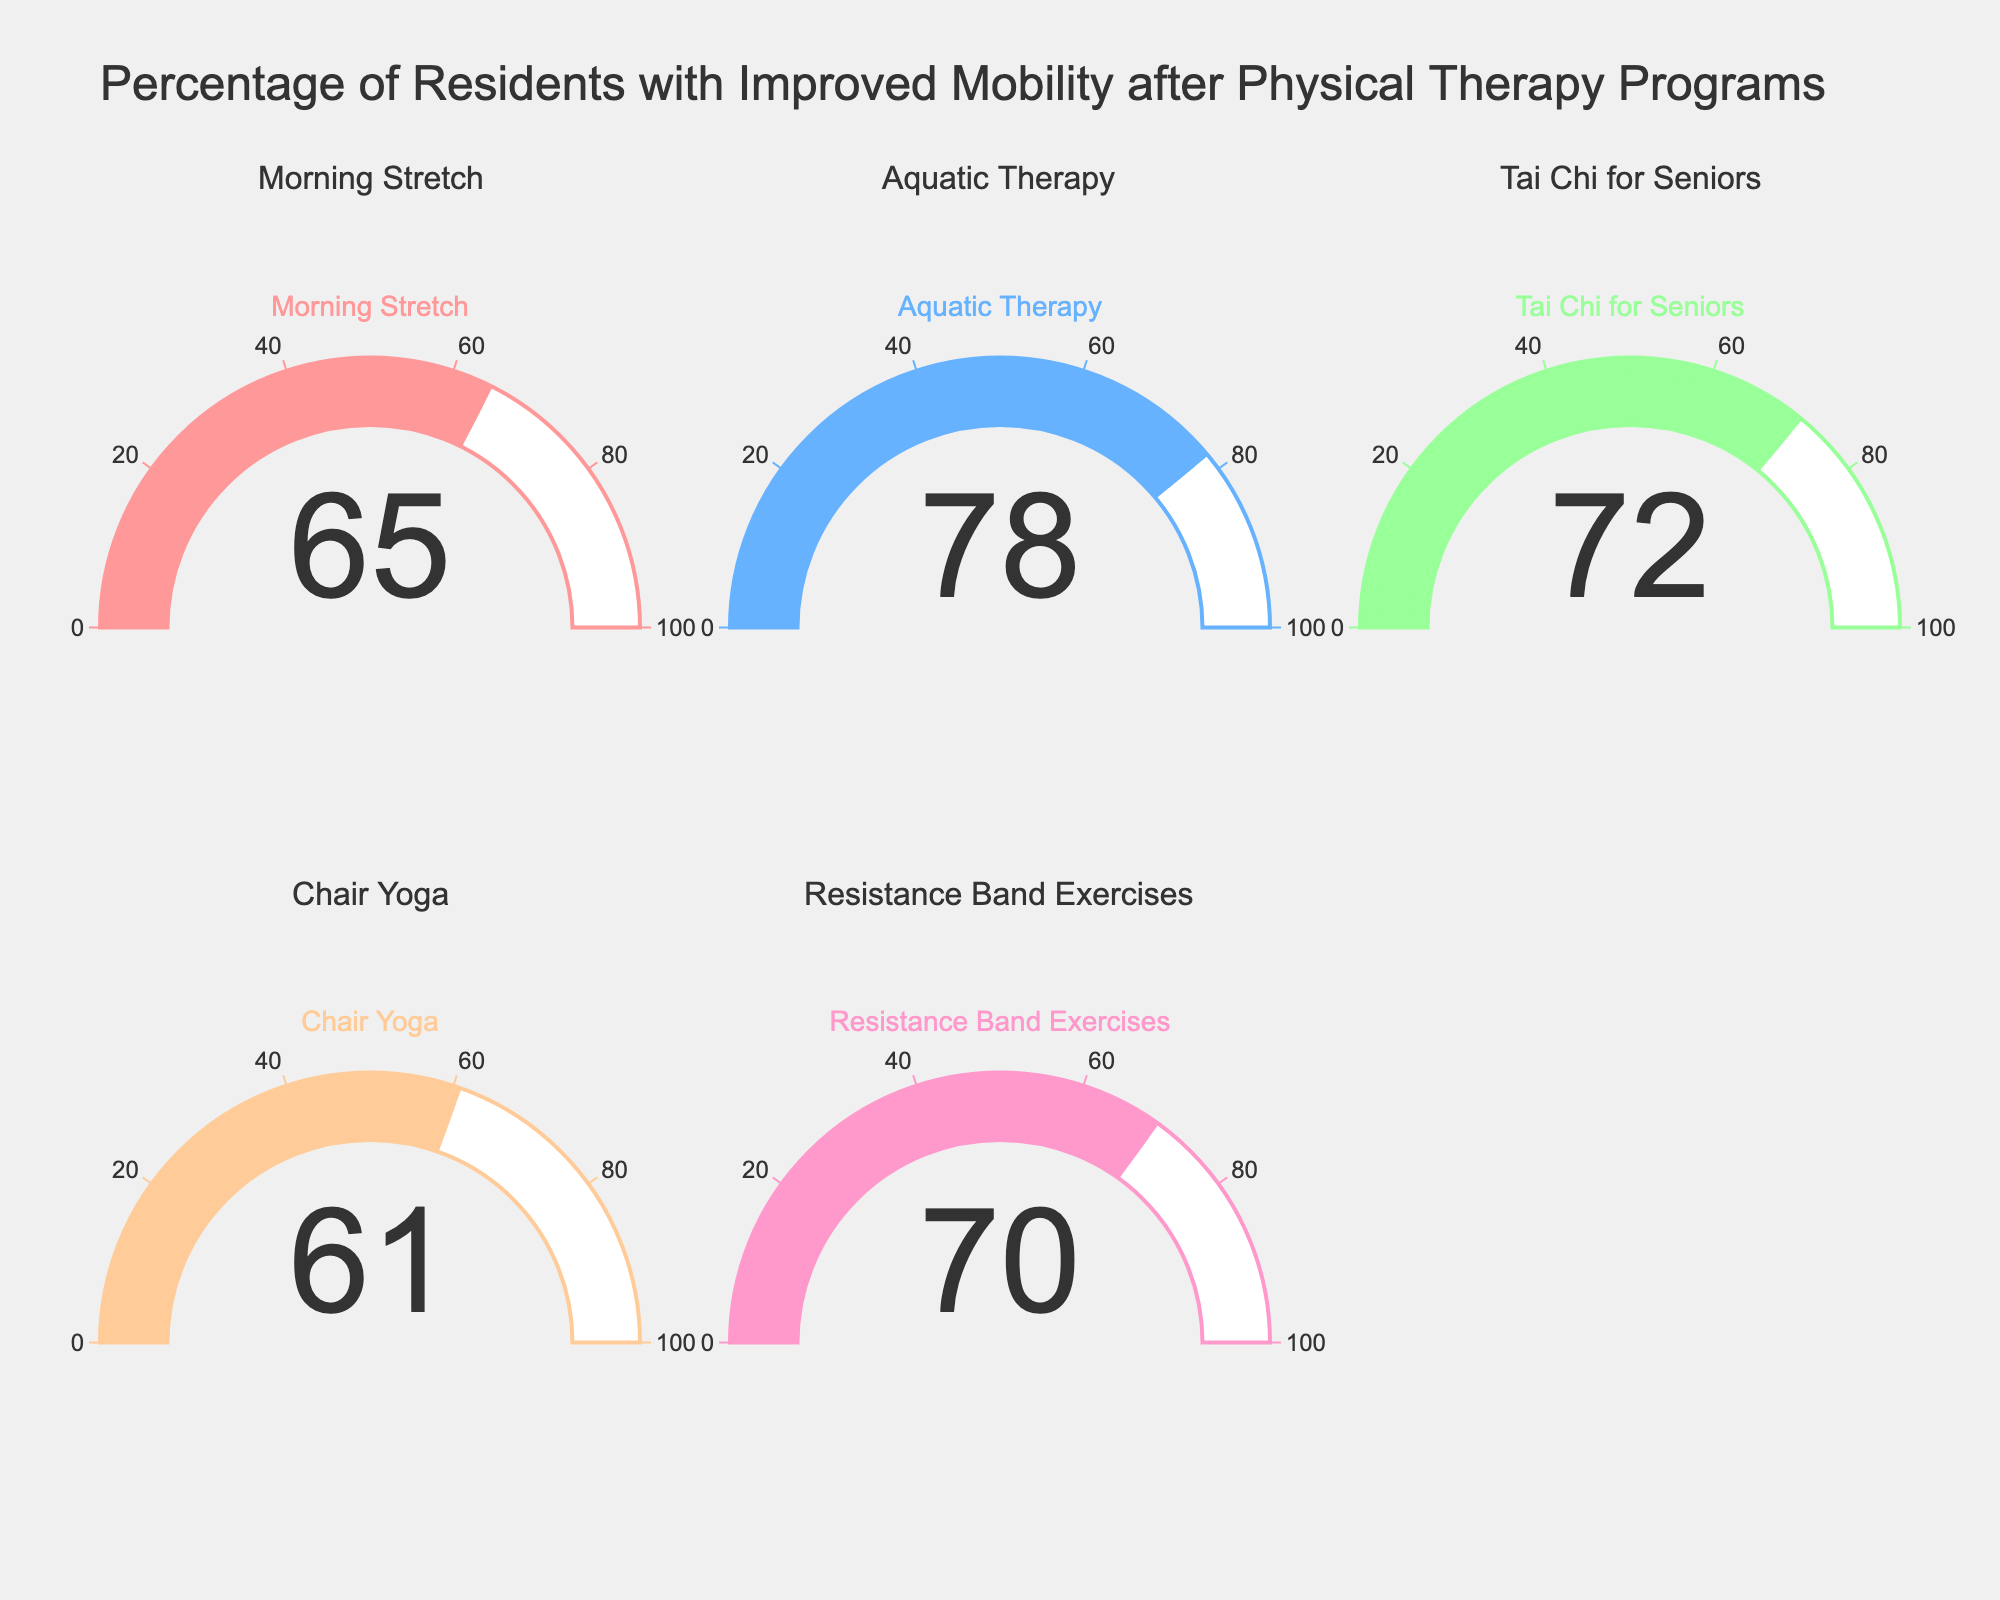What is the improvement percentage for Tai Chi for Seniors? Look at the Gauge Chart labeled "Tai Chi for Seniors" to find the percentage number.
Answer: 72 Which therapy has the highest improvement percentage? Compare all the percentages shown on the gauges and find the highest value. Aquatic Therapy shows 78%, which is the highest.
Answer: Aquatic Therapy How many therapy programs show an improvement percentage of over 70%? Check each gauge and count how many show a percentage greater than 70. Tai Chi for Seniors (72%), Resistance Band Exercises (70%), and Aquatic Therapy (78%) are over 70%.
Answer: 3 What is the combined improvement percentage of Chair Yoga and Morning Stretch? Add the percentages from the Chair Yoga (61%) and Morning Stretch (65%) gauges. 61 + 65 = 126.
Answer: 126 Which therapy has a lower improvement percentage, Chair Yoga or Morning Stretch? Compare the percentages; Chair Yoga shows 61% and Morning Stretch shows 65%.
Answer: Chair Yoga What is the average improvement percentage across all programs? Sum all the percentages and divide by the number of programs: (65 + 78 + 72 + 61 + 70) / 5 = 346 / 5 = 69.2.
Answer: 69.2 Is the improvement percentage for Resistance Band Exercises greater than the average improvement percentage? The average improvement percentage is 69.2. Resistance Band Exercises shows 70%, which is greater.
Answer: Yes What's the percentage difference between the highest and lowest improvement programs? Subtract the lowest percentage (Chair Yoga, 61%) from the highest percentage (Aquatic Therapy, 78%). 78 - 61 = 17.
Answer: 17 Which program has the median improvement percentage? Arrange the percentages in ascending order (61, 65, 70, 72, 78). The median value is the middle one, which is 70. Resistance Band Exercises shows 70%.
Answer: Resistance Band Exercises Which programs have an improvement percentage that falls below 65%? Identify the programs with percentages less than 65%. Chair Yoga is at 61%.
Answer: Chair Yoga 